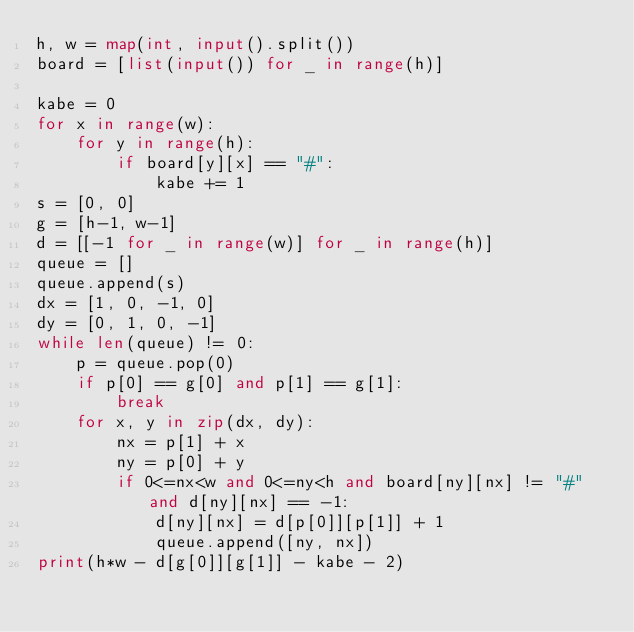Convert code to text. <code><loc_0><loc_0><loc_500><loc_500><_Python_>h, w = map(int, input().split())
board = [list(input()) for _ in range(h)]

kabe = 0
for x in range(w):
    for y in range(h):
        if board[y][x] == "#":
            kabe += 1
s = [0, 0]
g = [h-1, w-1]
d = [[-1 for _ in range(w)] for _ in range(h)]
queue = []
queue.append(s)
dx = [1, 0, -1, 0]
dy = [0, 1, 0, -1]
while len(queue) != 0:
    p = queue.pop(0)
    if p[0] == g[0] and p[1] == g[1]:
        break
    for x, y in zip(dx, dy):
        nx = p[1] + x
        ny = p[0] + y
        if 0<=nx<w and 0<=ny<h and board[ny][nx] != "#" and d[ny][nx] == -1:
            d[ny][nx] = d[p[0]][p[1]] + 1
            queue.append([ny, nx])
print(h*w - d[g[0]][g[1]] - kabe - 2)</code> 